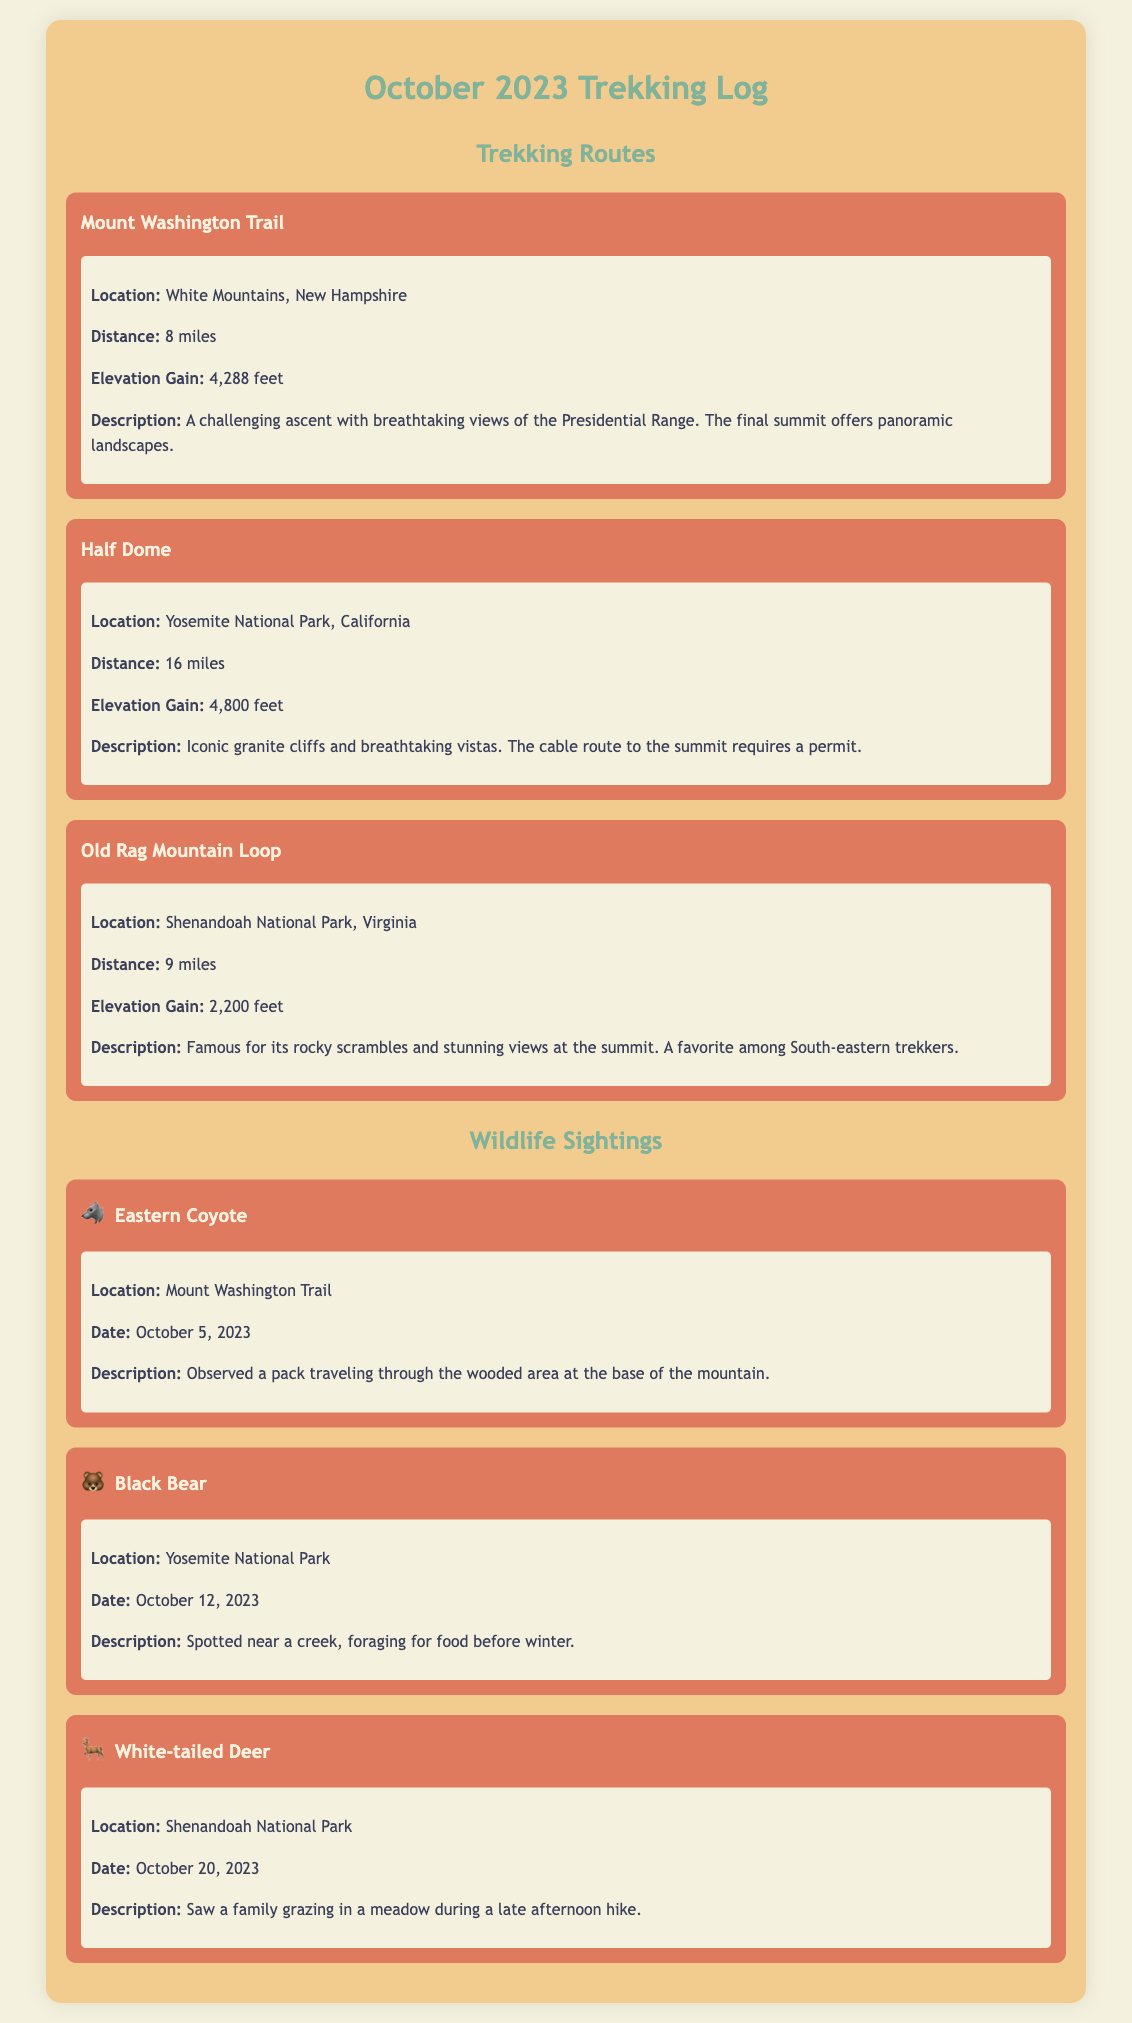What is the total distance of Half Dome? The total distance of Half Dome is specified in the document as 16 miles.
Answer: 16 miles What wildlife was spotted at Mount Washington Trail? The wildlife sighting at Mount Washington Trail includes an Eastern Coyote.
Answer: Eastern Coyote What is the elevation gain for the Old Rag Mountain Loop? The elevation gain for the Old Rag Mountain Loop is listed as 2,200 feet.
Answer: 2,200 feet Which location had a Black Bear sighting? The Black Bear was spotted at Yosemite National Park.
Answer: Yosemite National Park What is the distance of Mount Washington Trail? The distance of Mount Washington Trail is noted as 8 miles.
Answer: 8 miles Which trek has the highest elevation gain? Half Dome has the highest elevation gain at 4,800 feet.
Answer: Half Dome How many wildlife sightings are recorded in the log? The document contains three wildlife sightings.
Answer: Three What date was the White-tailed Deer sighted? The White-tailed Deer was sighted on October 20, 2023.
Answer: October 20, 2023 What is the main feature of the Half Dome trek? The main feature of the Half Dome trek is its iconic granite cliffs.
Answer: Iconic granite cliffs 